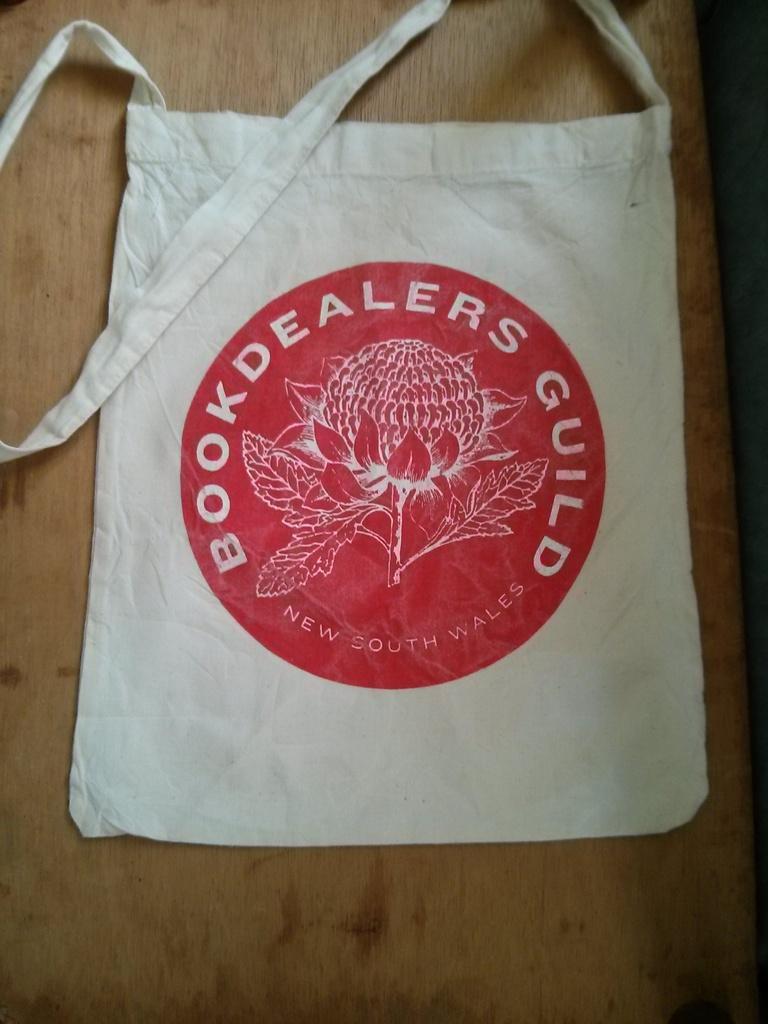Describe this image in one or two sentences. In this picture, this is a white bag on the bag it is written as a book dealers guild. The white bag is on a wooden table. 